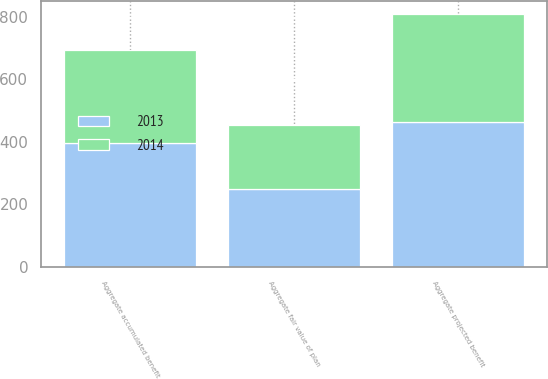<chart> <loc_0><loc_0><loc_500><loc_500><stacked_bar_chart><ecel><fcel>Aggregate projected benefit<fcel>Aggregate accumulated benefit<fcel>Aggregate fair value of plan<nl><fcel>2013<fcel>461.8<fcel>396.3<fcel>248.4<nl><fcel>2014<fcel>347.1<fcel>298.5<fcel>204.6<nl></chart> 